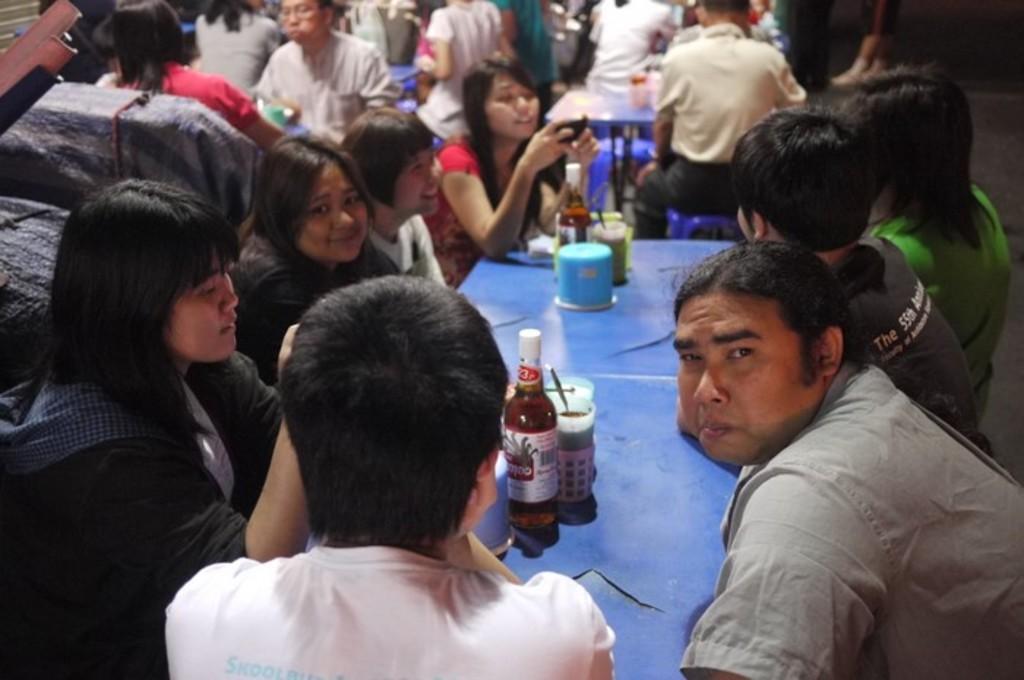In one or two sentences, can you explain what this image depicts? There is a group of people. They are sitting on a chairs. In the center of the woman is holding a mobile. There is a table. There is a bottle,glass,spoon on a table. There is a another table in the center. There is a bowl on the center. 